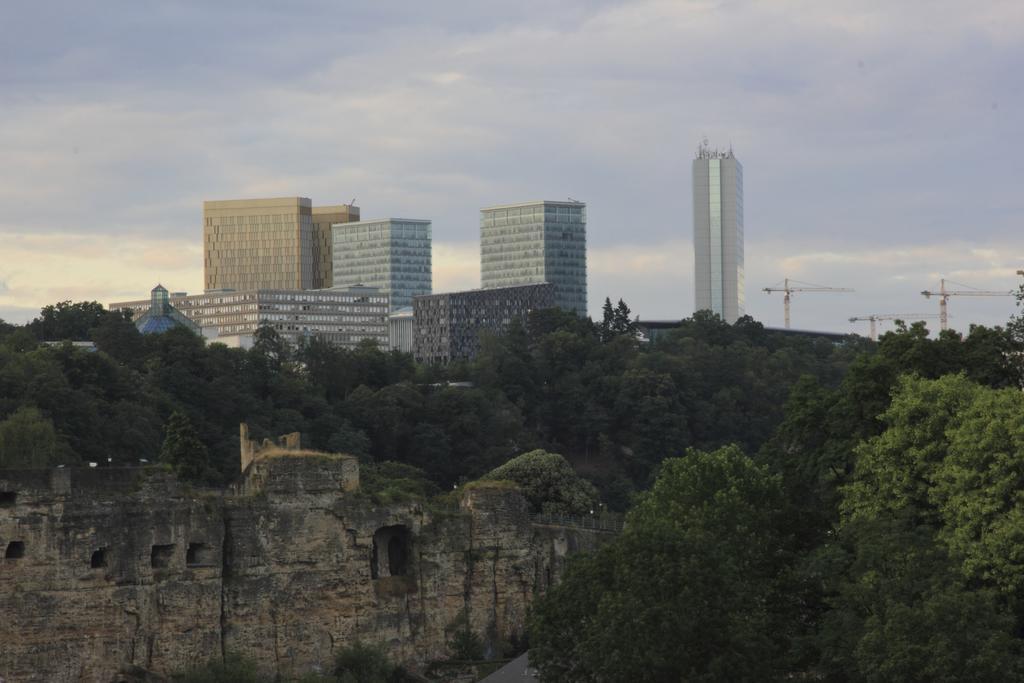In one or two sentences, can you explain what this image depicts? In this image I can see a historical structure and few trees around it. In the background I can see few buildings, few cranes and the sky. 